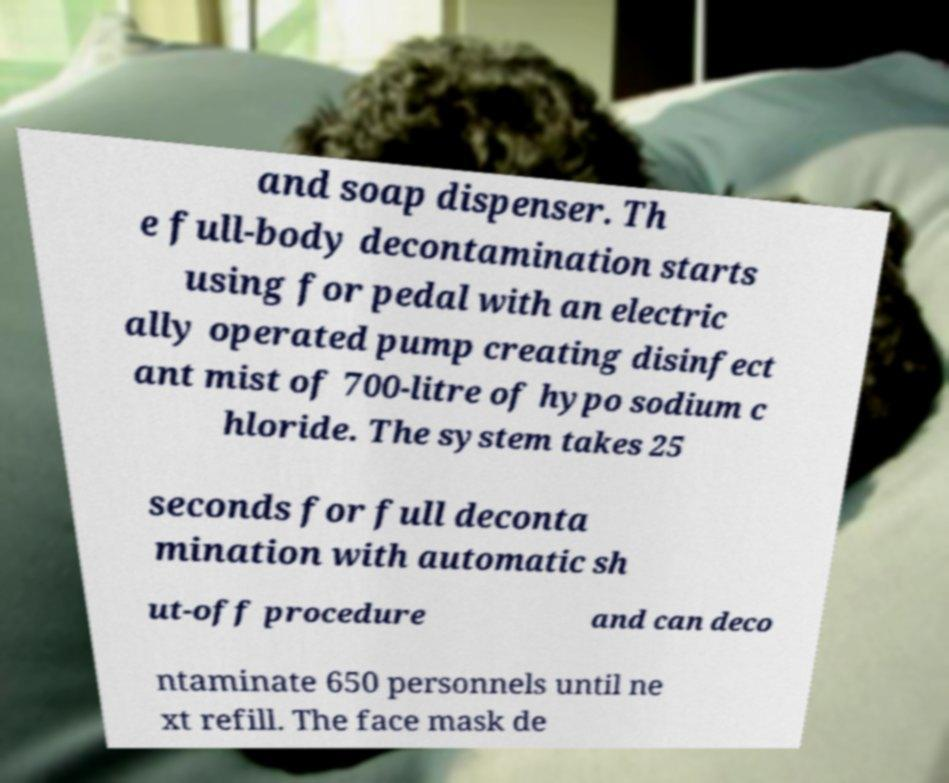Can you accurately transcribe the text from the provided image for me? and soap dispenser. Th e full-body decontamination starts using for pedal with an electric ally operated pump creating disinfect ant mist of 700-litre of hypo sodium c hloride. The system takes 25 seconds for full deconta mination with automatic sh ut-off procedure and can deco ntaminate 650 personnels until ne xt refill. The face mask de 